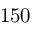<formula> <loc_0><loc_0><loc_500><loc_500>1 5 0</formula> 